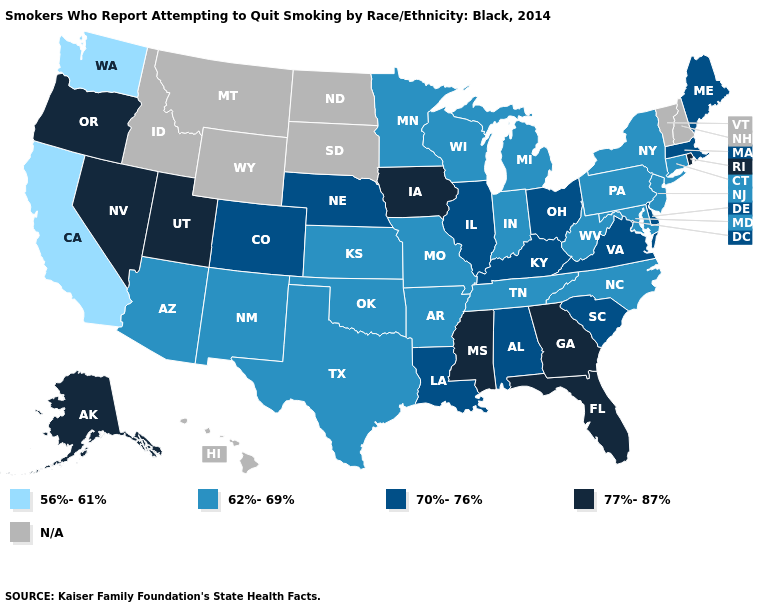What is the lowest value in the USA?
Give a very brief answer. 56%-61%. How many symbols are there in the legend?
Answer briefly. 5. Does the map have missing data?
Concise answer only. Yes. Name the states that have a value in the range 56%-61%?
Answer briefly. California, Washington. Among the states that border Wisconsin , does Iowa have the highest value?
Quick response, please. Yes. What is the value of New York?
Be succinct. 62%-69%. Name the states that have a value in the range 56%-61%?
Keep it brief. California, Washington. How many symbols are there in the legend?
Quick response, please. 5. Name the states that have a value in the range 56%-61%?
Give a very brief answer. California, Washington. Among the states that border South Carolina , which have the highest value?
Write a very short answer. Georgia. What is the highest value in the Northeast ?
Concise answer only. 77%-87%. Name the states that have a value in the range 62%-69%?
Concise answer only. Arizona, Arkansas, Connecticut, Indiana, Kansas, Maryland, Michigan, Minnesota, Missouri, New Jersey, New Mexico, New York, North Carolina, Oklahoma, Pennsylvania, Tennessee, Texas, West Virginia, Wisconsin. Which states have the lowest value in the MidWest?
Be succinct. Indiana, Kansas, Michigan, Minnesota, Missouri, Wisconsin. Does New Jersey have the lowest value in the Northeast?
Short answer required. Yes. 